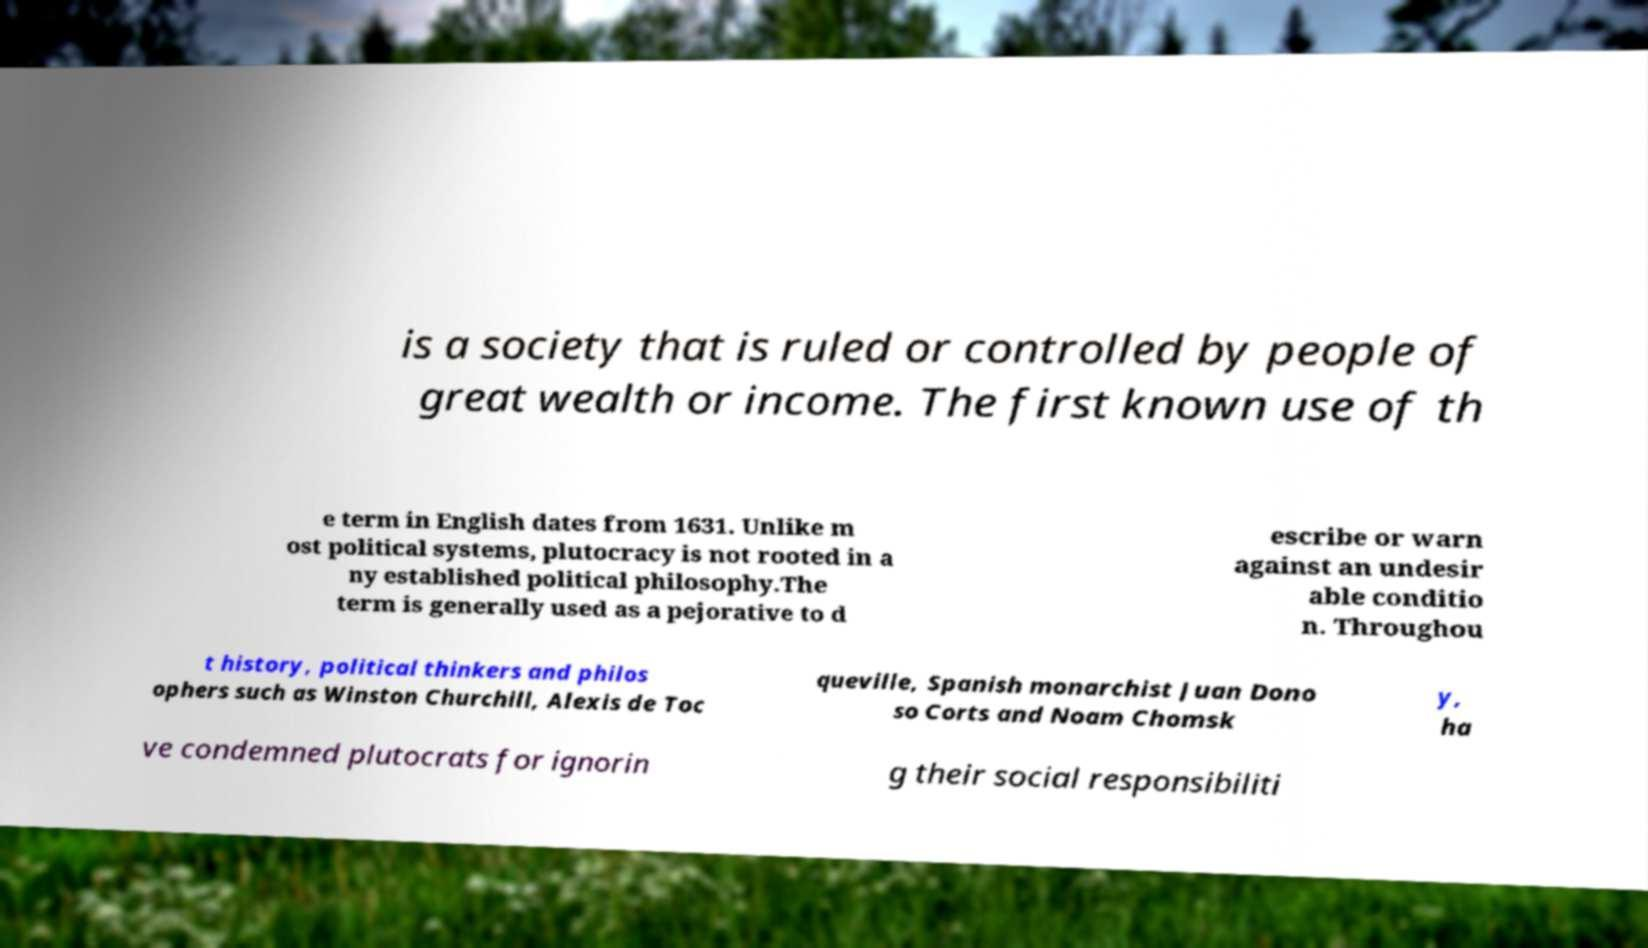Can you read and provide the text displayed in the image?This photo seems to have some interesting text. Can you extract and type it out for me? is a society that is ruled or controlled by people of great wealth or income. The first known use of th e term in English dates from 1631. Unlike m ost political systems, plutocracy is not rooted in a ny established political philosophy.The term is generally used as a pejorative to d escribe or warn against an undesir able conditio n. Throughou t history, political thinkers and philos ophers such as Winston Churchill, Alexis de Toc queville, Spanish monarchist Juan Dono so Corts and Noam Chomsk y, ha ve condemned plutocrats for ignorin g their social responsibiliti 